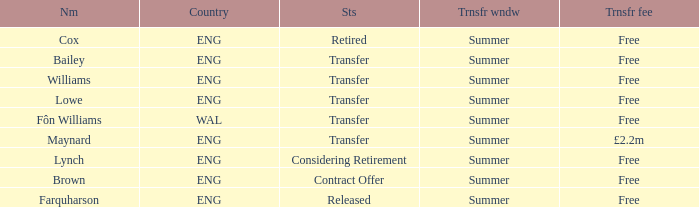What is the transfer window with a status of transfer from the country of Wal? Summer. 